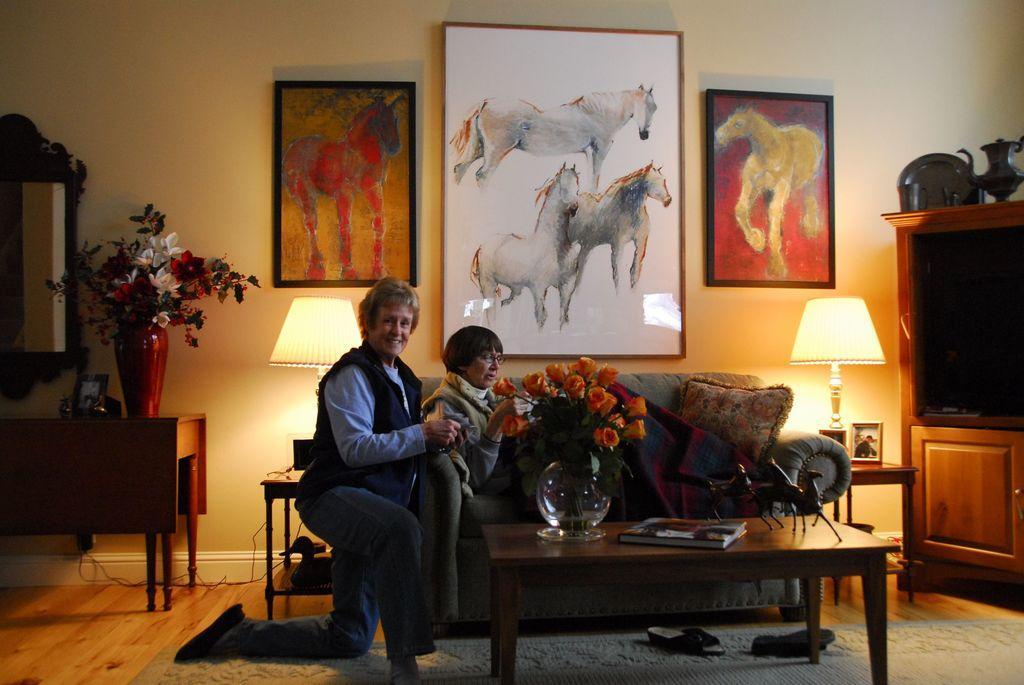How would you summarize this image in a sentence or two? This image is clicked in a room. There are photo frames on the wall. There is a flower pot on the left side. There is a mirror on the left side. In the middle there is a sofa and there is a table. On the sofa there is a woman and beside her there is a man standing. On the table there is a fish pot and a book. There is a TV on the right side. There is a light on the right side. 